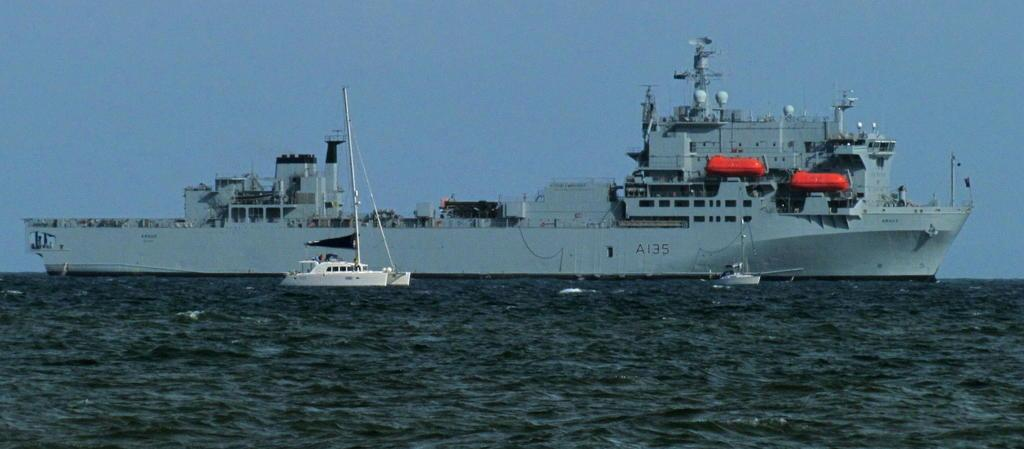<image>
Render a clear and concise summary of the photo. a big ship has serial number A135 on the side 